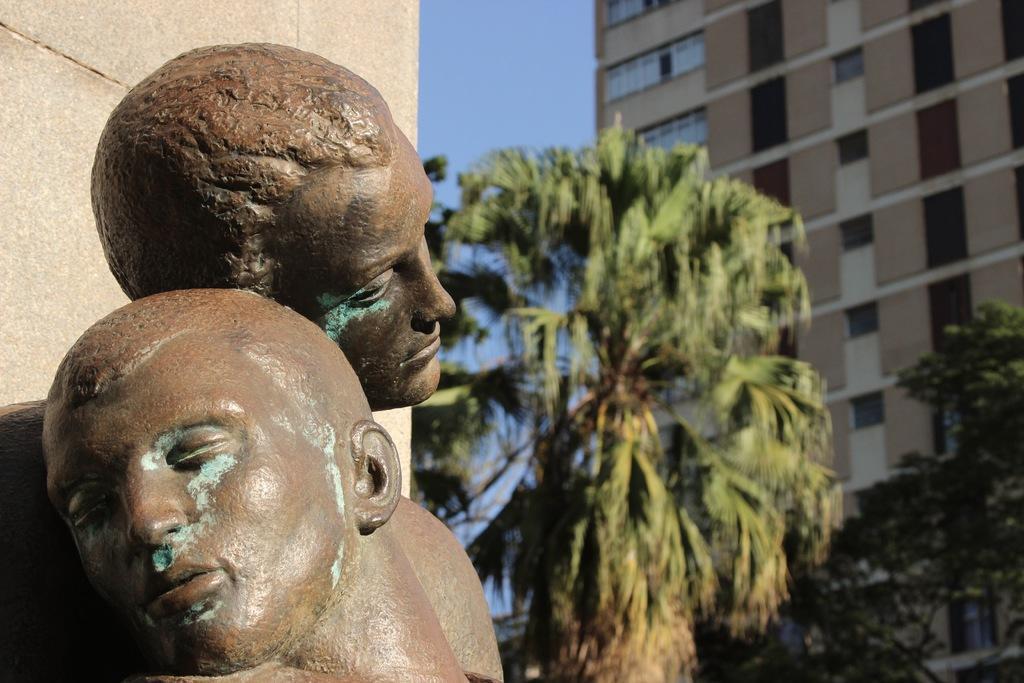Describe this image in one or two sentences. In this image I see the wall and I see sculptures over here which is of brown in color. In the background I see the trees, a building and the blue sky. 